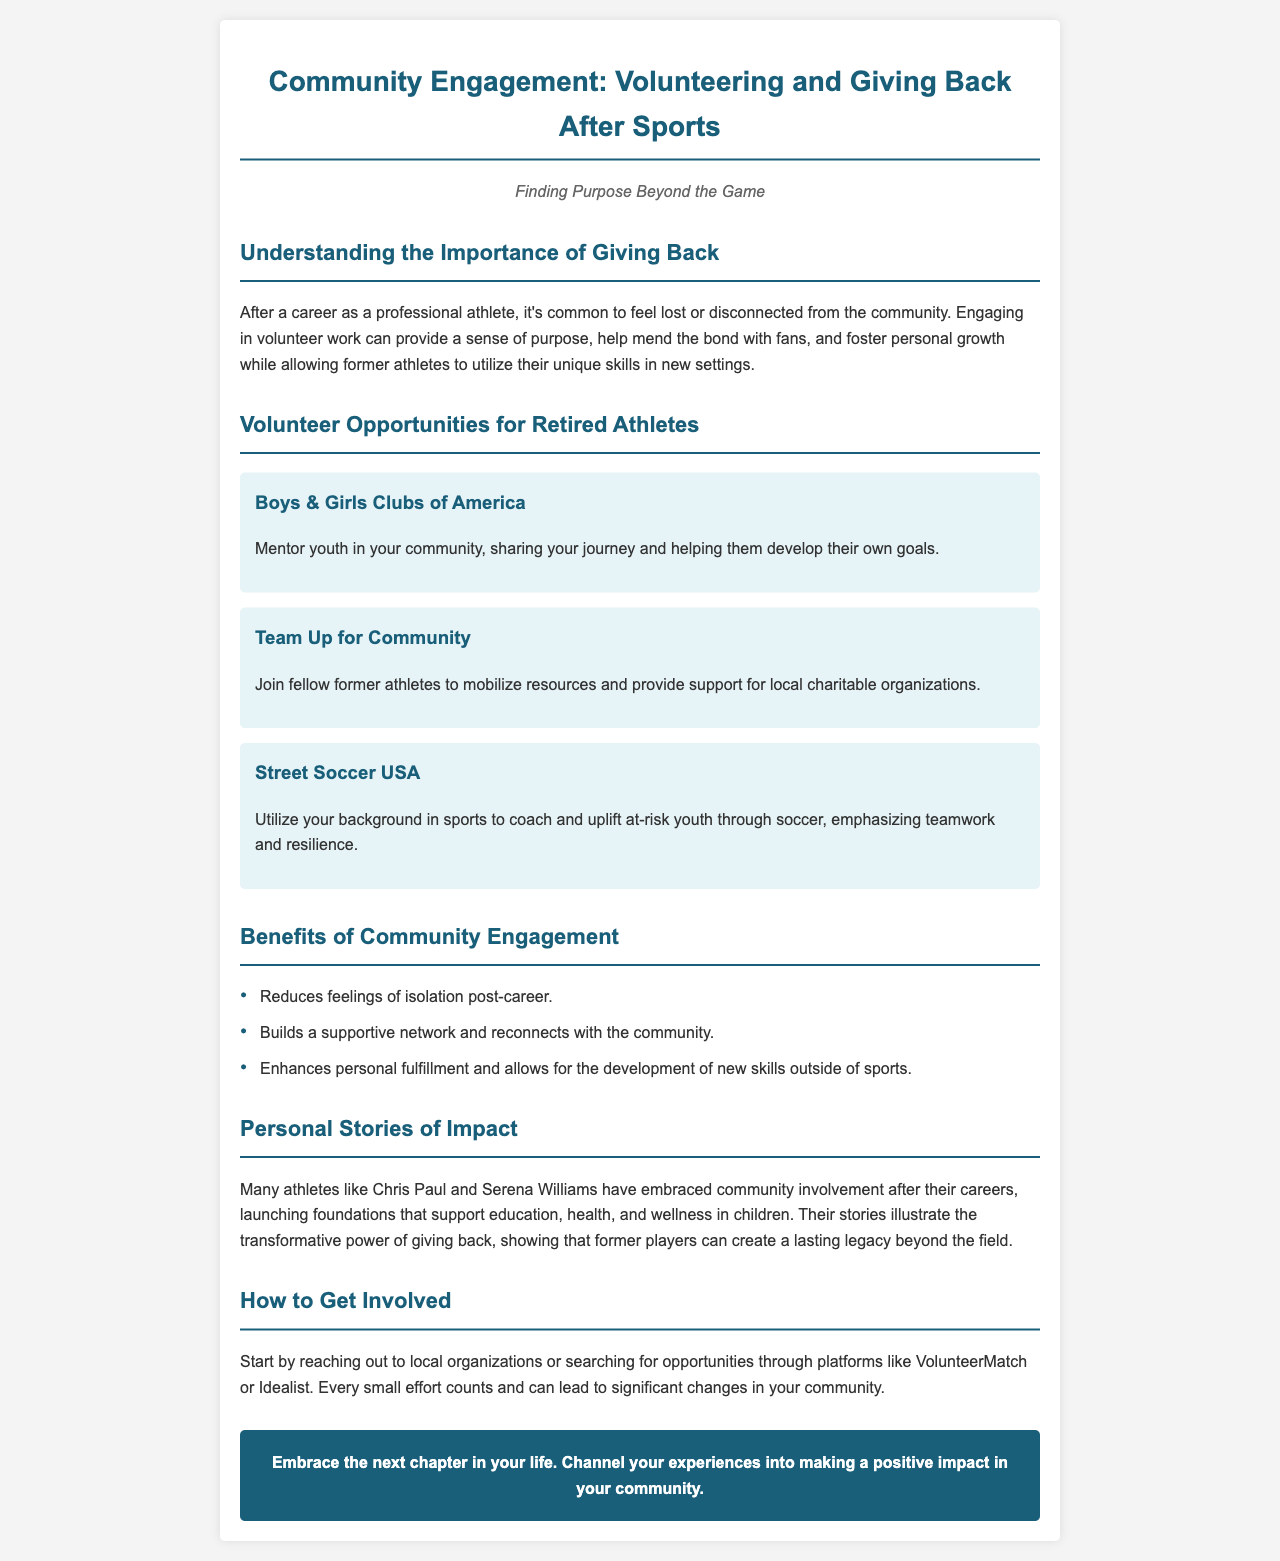What is the title of the brochure? The title is stated at the top of the document, highlighting the main topic of engagement after sports.
Answer: Community Engagement: Volunteering and Giving Back After Sports What organization is mentioned for mentoring youth? The document lists various volunteer opportunities, one of which focuses on mentoring young people.
Answer: Boys & Girls Clubs of America How many benefits of community engagement are listed? The document presents a list of benefits, and counting them will provide the answer.
Answer: Three Which athlete is referenced in relation to community involvement? The document mentions specific athletes known for their charitable work.
Answer: Chris Paul What is one way to start getting involved in community engagement? The document suggests a method to begin participation in community service.
Answer: Reaching out to local organizations What color represents the background of the brochure? The color scheme is highlighted in the styling portion of the document.
Answer: Light gray What type of youth does Street Soccer USA focus on? The document specifies the target demographic for this volunteer opportunity.
Answer: At-risk youth What is emphasized in coaching at Street Soccer USA? The document describes the focus areas for coaching within this organization.
Answer: Teamwork and resilience 